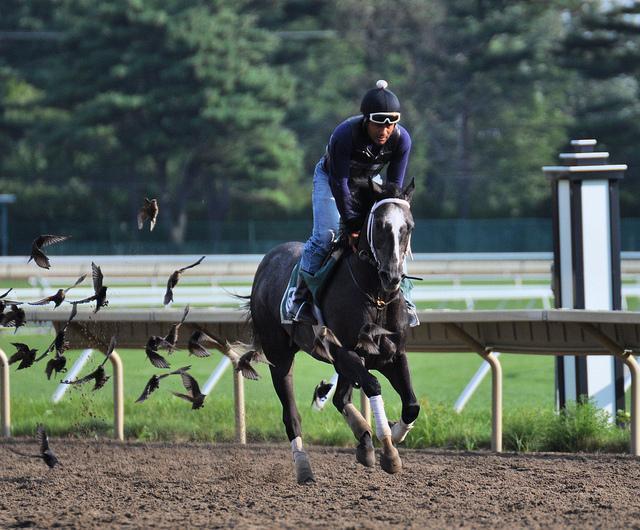How many people are in the foto?
Give a very brief answer. 1. How many horses are seen?
Give a very brief answer. 1. 